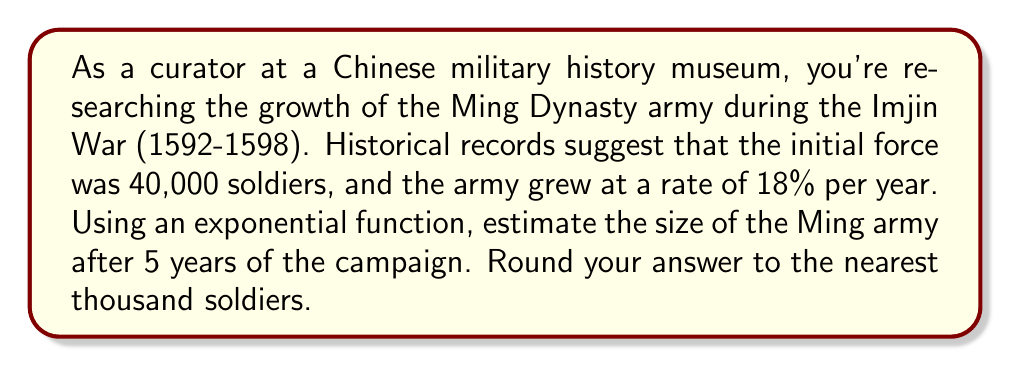Could you help me with this problem? To solve this problem, we'll use the exponential growth function:

$$A(t) = A_0(1 + r)^t$$

Where:
$A(t)$ is the amount after time $t$
$A_0$ is the initial amount
$r$ is the growth rate (as a decimal)
$t$ is the time period

Given:
$A_0 = 40,000$ (initial force)
$r = 0.18$ (18% growth rate)
$t = 5$ years

Let's substitute these values into the equation:

$$A(5) = 40,000(1 + 0.18)^5$$

Now, let's calculate step by step:

1) First, calculate $(1 + 0.18)^5$:
   $$(1.18)^5 = 2.2877$$

2) Multiply this by the initial force:
   $$40,000 \times 2.2877 = 91,508$$

3) Round to the nearest thousand:
   $91,508 \approx 92,000$

Therefore, after 5 years, the estimated size of the Ming army would be approximately 92,000 soldiers.
Answer: 92,000 soldiers 